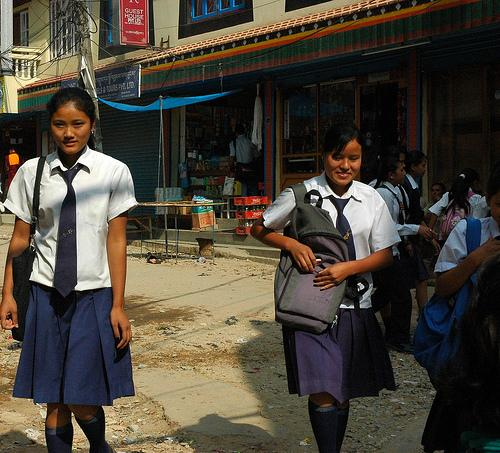How many girls are wearing blue and white outfits? There are three girls wearing blue and white outfits. Count the number of items in the backpack area mentioned in the captions. There are seven items related to the backpack area: black bag, girl carrying a backpack, girl opening a backpack, girl putting something in a backpack, girl with a black bag, blue backpack over the girl's shoulder, and blue and black backpack. Narrate the prominent activity of the girl in the image. The girl is smiling and interacting with her backpack. What is the color and style of the girl's skirt? The girl's skirt is blue with plaits and pleated. Explain the general sentiment perceived from the image. The general sentiment perceived from the image is positive, with cheerfulness among the girls. Describe one object present in front of the store. There is a table with an umbrella over it in front of the store. What is one item the store uses for shade? The store uses a blue tarp as awning for shade. Can you detect any objects on the ground near the store? There are soda racks, rocks, trash, and a cardboard box on the ground near the store. What is the dominant color of the girl's outfit? The dominant color of the girl's outfit is blue. How many girls in school uniforms can be seen in the image? There are several girls in school uniforms, forming a crowd. 